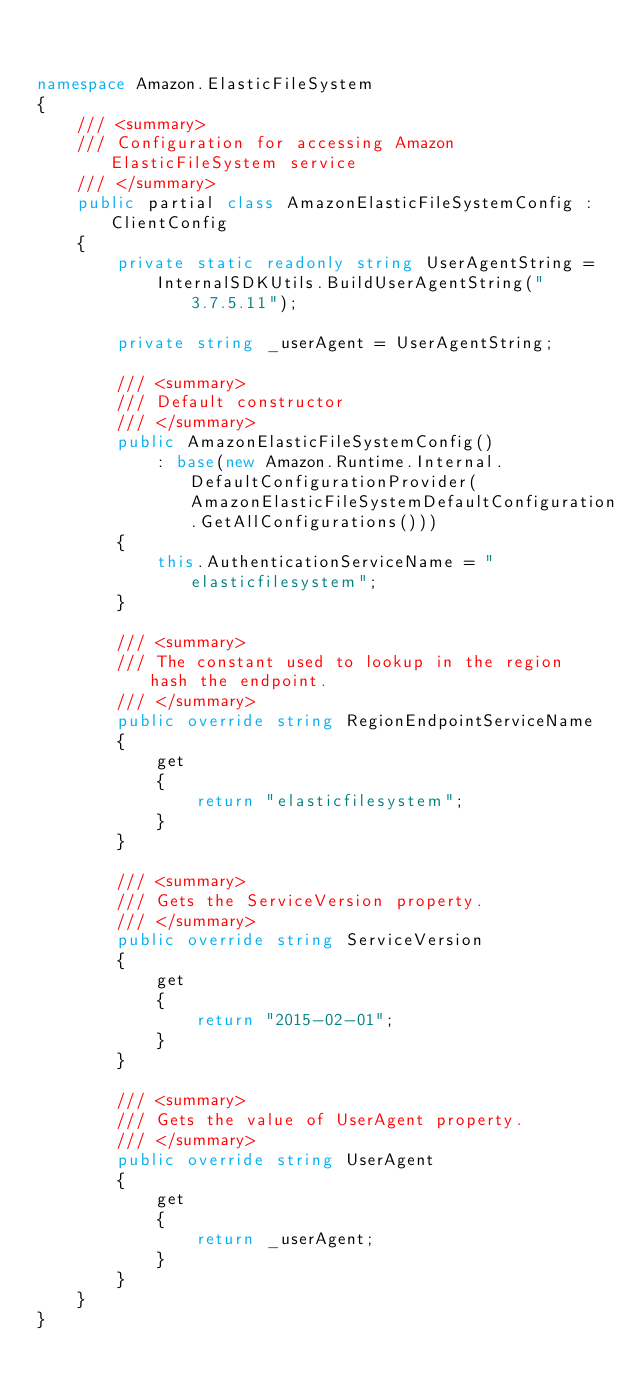Convert code to text. <code><loc_0><loc_0><loc_500><loc_500><_C#_>

namespace Amazon.ElasticFileSystem
{
    /// <summary>
    /// Configuration for accessing Amazon ElasticFileSystem service
    /// </summary>
    public partial class AmazonElasticFileSystemConfig : ClientConfig
    {
        private static readonly string UserAgentString =
            InternalSDKUtils.BuildUserAgentString("3.7.5.11");

        private string _userAgent = UserAgentString;

        /// <summary>
        /// Default constructor
        /// </summary>
        public AmazonElasticFileSystemConfig()
            : base(new Amazon.Runtime.Internal.DefaultConfigurationProvider(AmazonElasticFileSystemDefaultConfiguration.GetAllConfigurations()))
        {
            this.AuthenticationServiceName = "elasticfilesystem";
        }

        /// <summary>
        /// The constant used to lookup in the region hash the endpoint.
        /// </summary>
        public override string RegionEndpointServiceName
        {
            get
            {
                return "elasticfilesystem";
            }
        }

        /// <summary>
        /// Gets the ServiceVersion property.
        /// </summary>
        public override string ServiceVersion
        {
            get
            {
                return "2015-02-01";
            }
        }

        /// <summary>
        /// Gets the value of UserAgent property.
        /// </summary>
        public override string UserAgent
        {
            get
            {
                return _userAgent;
            }
        }
    }
}</code> 